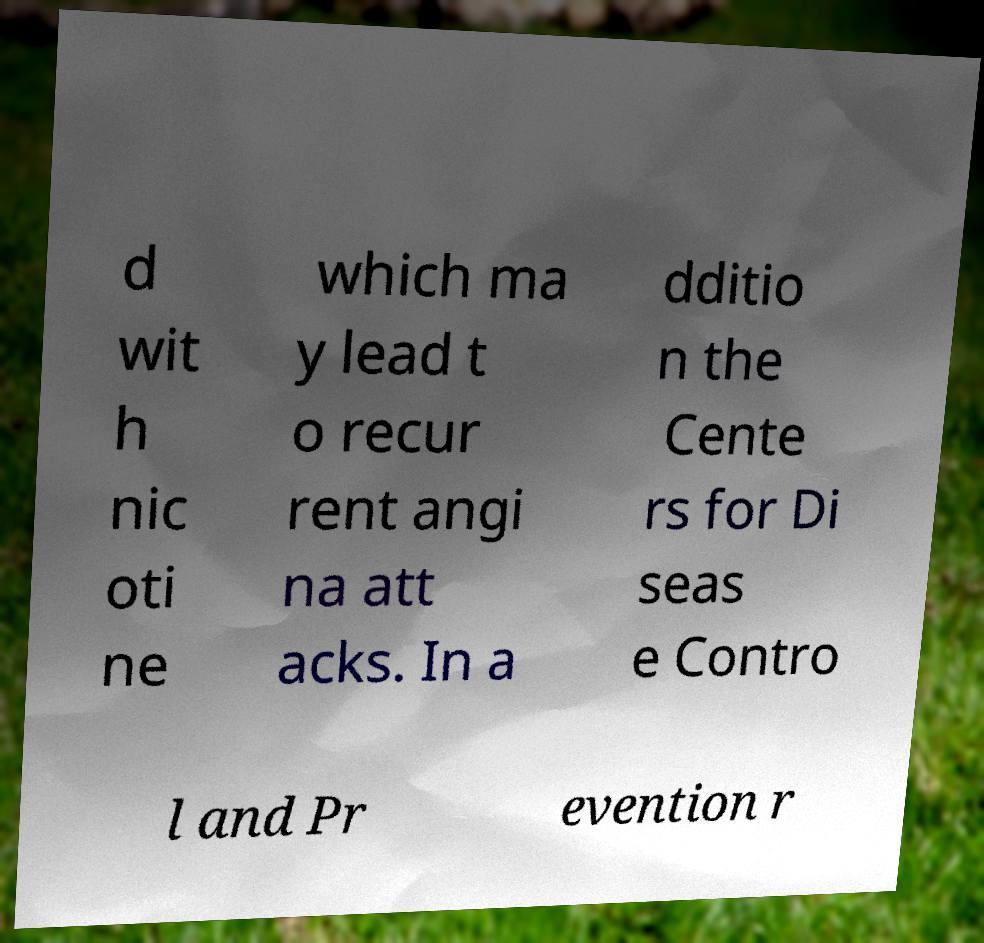Could you extract and type out the text from this image? d wit h nic oti ne which ma y lead t o recur rent angi na att acks. In a dditio n the Cente rs for Di seas e Contro l and Pr evention r 